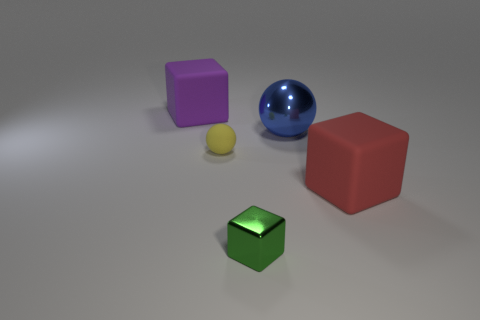Add 4 small green blocks. How many objects exist? 9 Subtract all spheres. How many objects are left? 3 Add 3 large blue spheres. How many large blue spheres are left? 4 Add 5 tiny cyan rubber objects. How many tiny cyan rubber objects exist? 5 Subtract 0 blue cylinders. How many objects are left? 5 Subtract all big purple blocks. Subtract all matte blocks. How many objects are left? 2 